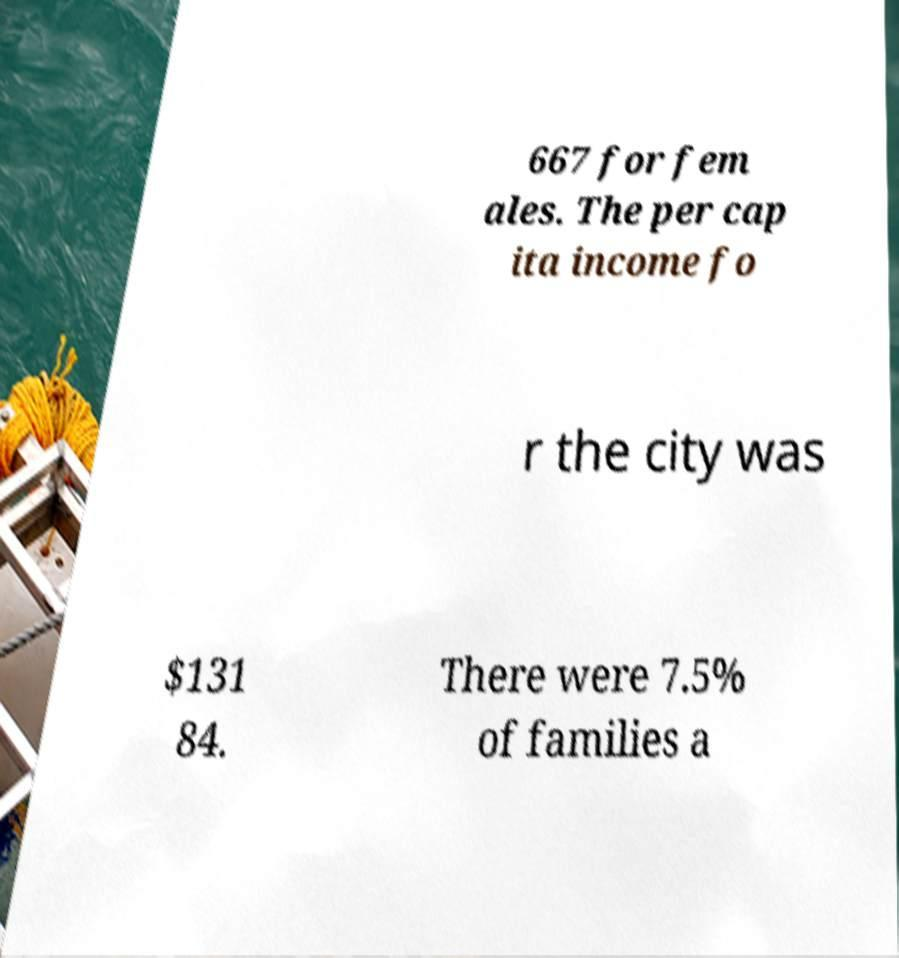I need the written content from this picture converted into text. Can you do that? 667 for fem ales. The per cap ita income fo r the city was $131 84. There were 7.5% of families a 